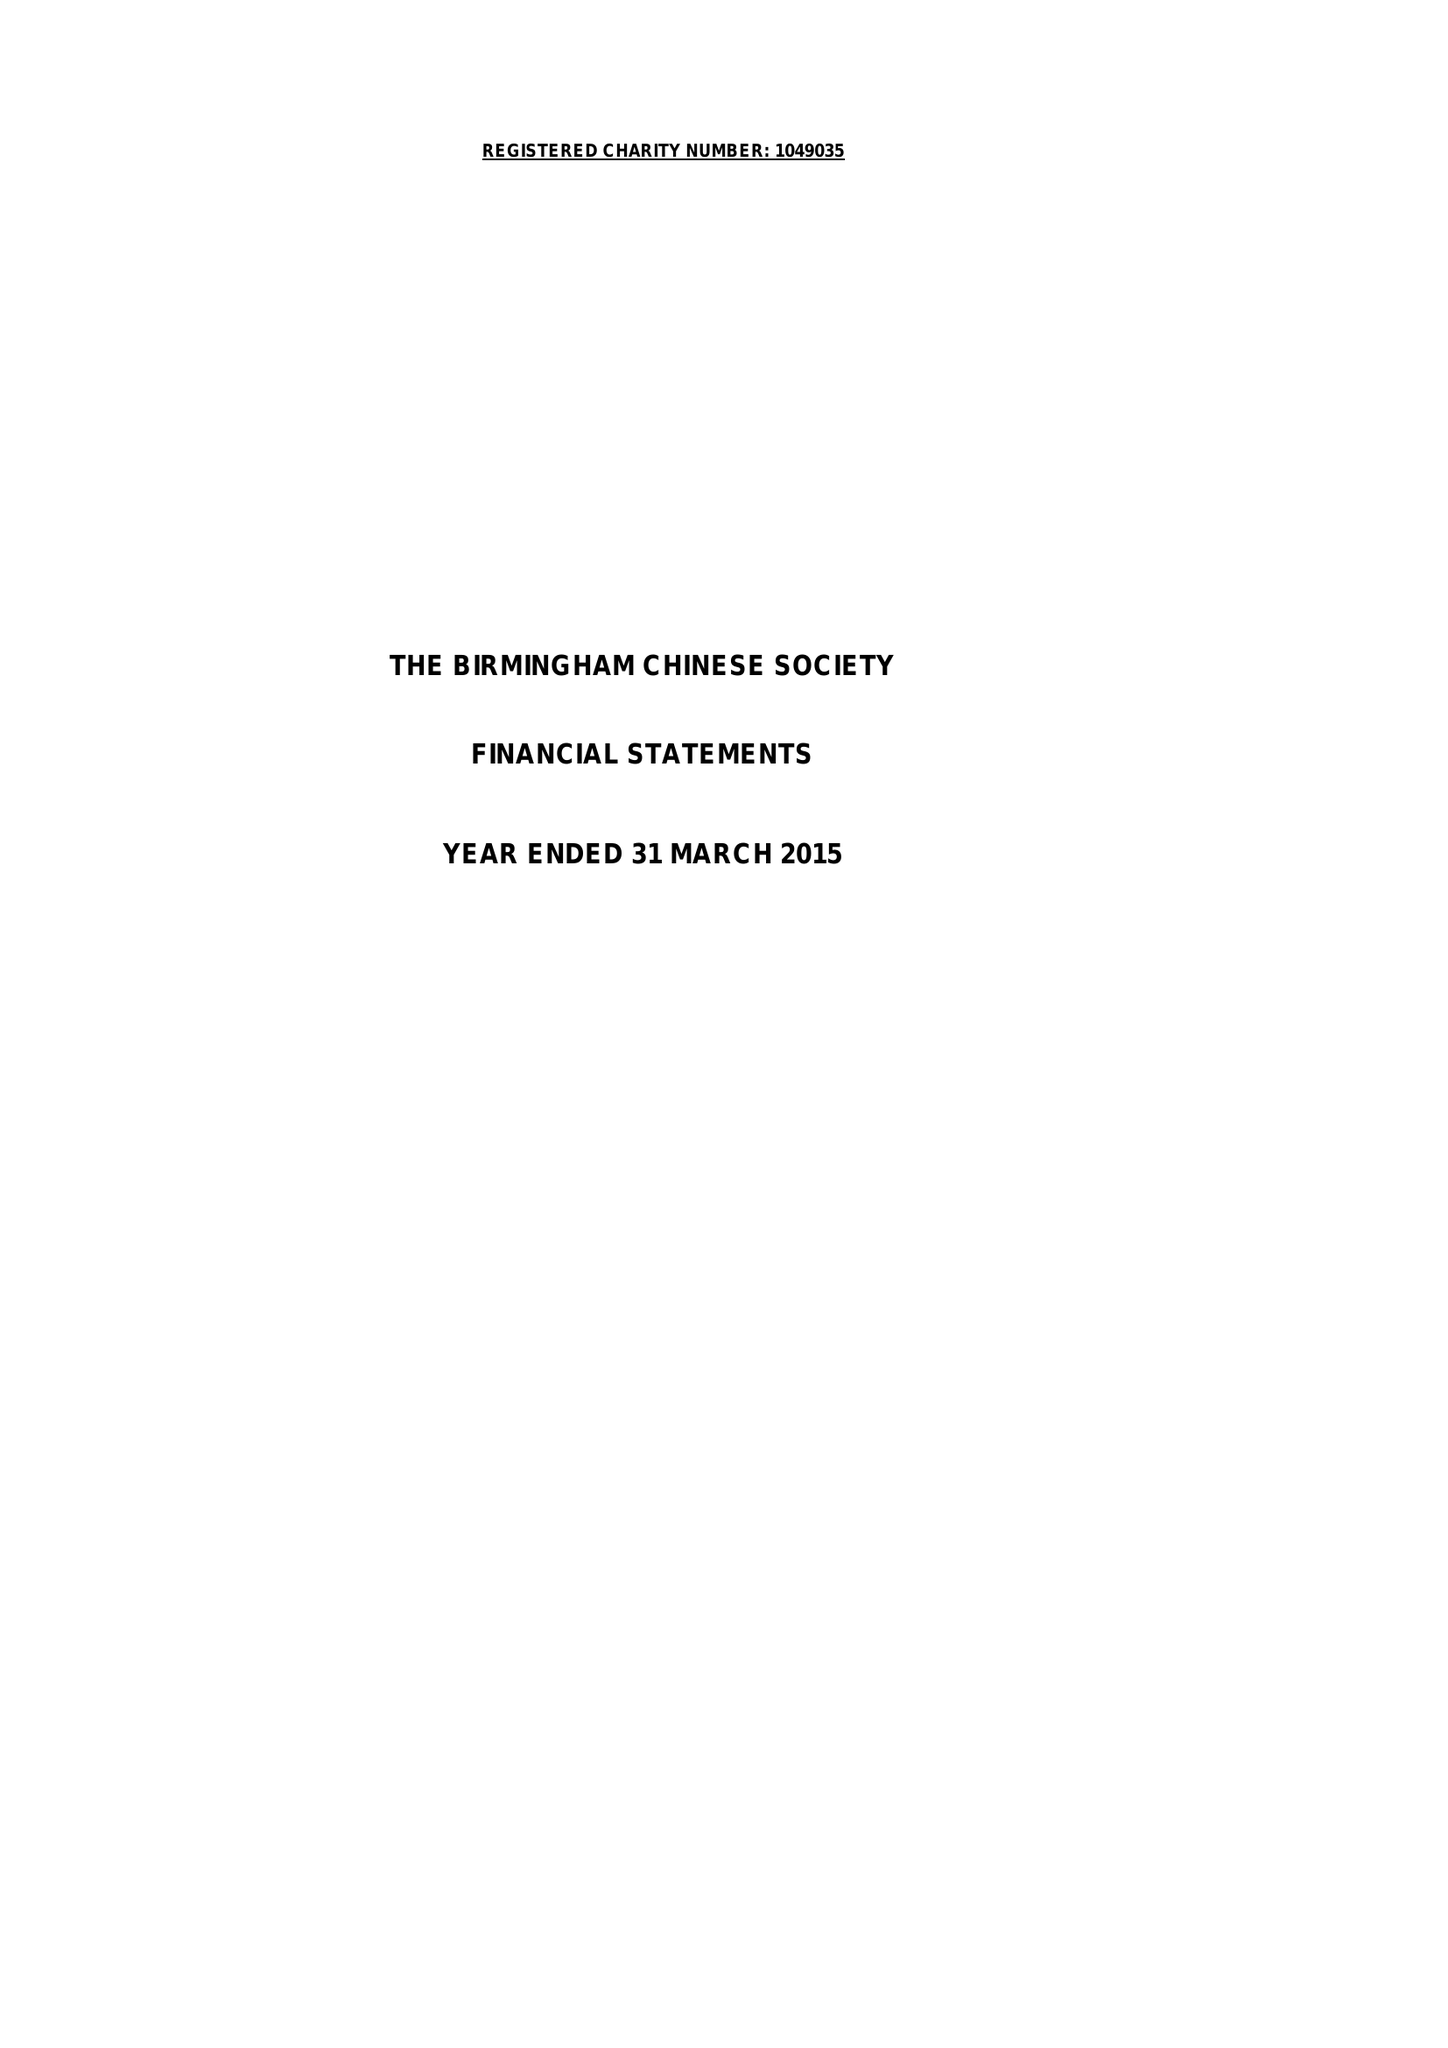What is the value for the charity_number?
Answer the question using a single word or phrase. 1049035 